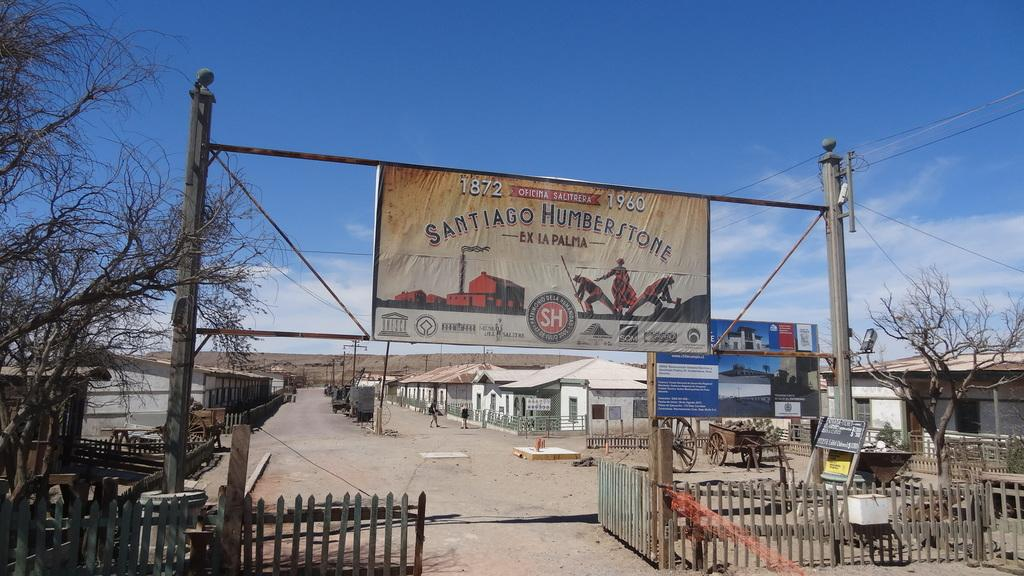Provide a one-sentence caption for the provided image. A sign saying Santiago Humberstone with the years 1872 and 1960 on it. 